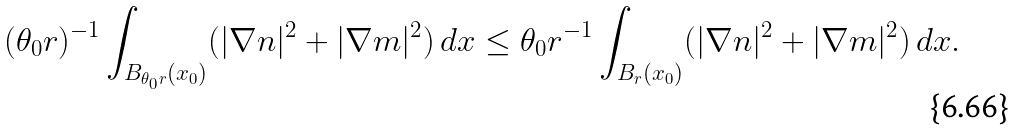Convert formula to latex. <formula><loc_0><loc_0><loc_500><loc_500>( \theta _ { 0 } r ) ^ { - 1 } \int _ { B _ { \theta _ { 0 } r } ( x _ { 0 } ) } ( | \nabla n | ^ { 2 } + | \nabla m | ^ { 2 } ) \, d x \leq \theta _ { 0 } r ^ { - 1 } \int _ { B _ { r } ( x _ { 0 } ) } ( | \nabla n | ^ { 2 } + | \nabla m | ^ { 2 } ) \, d x .</formula> 